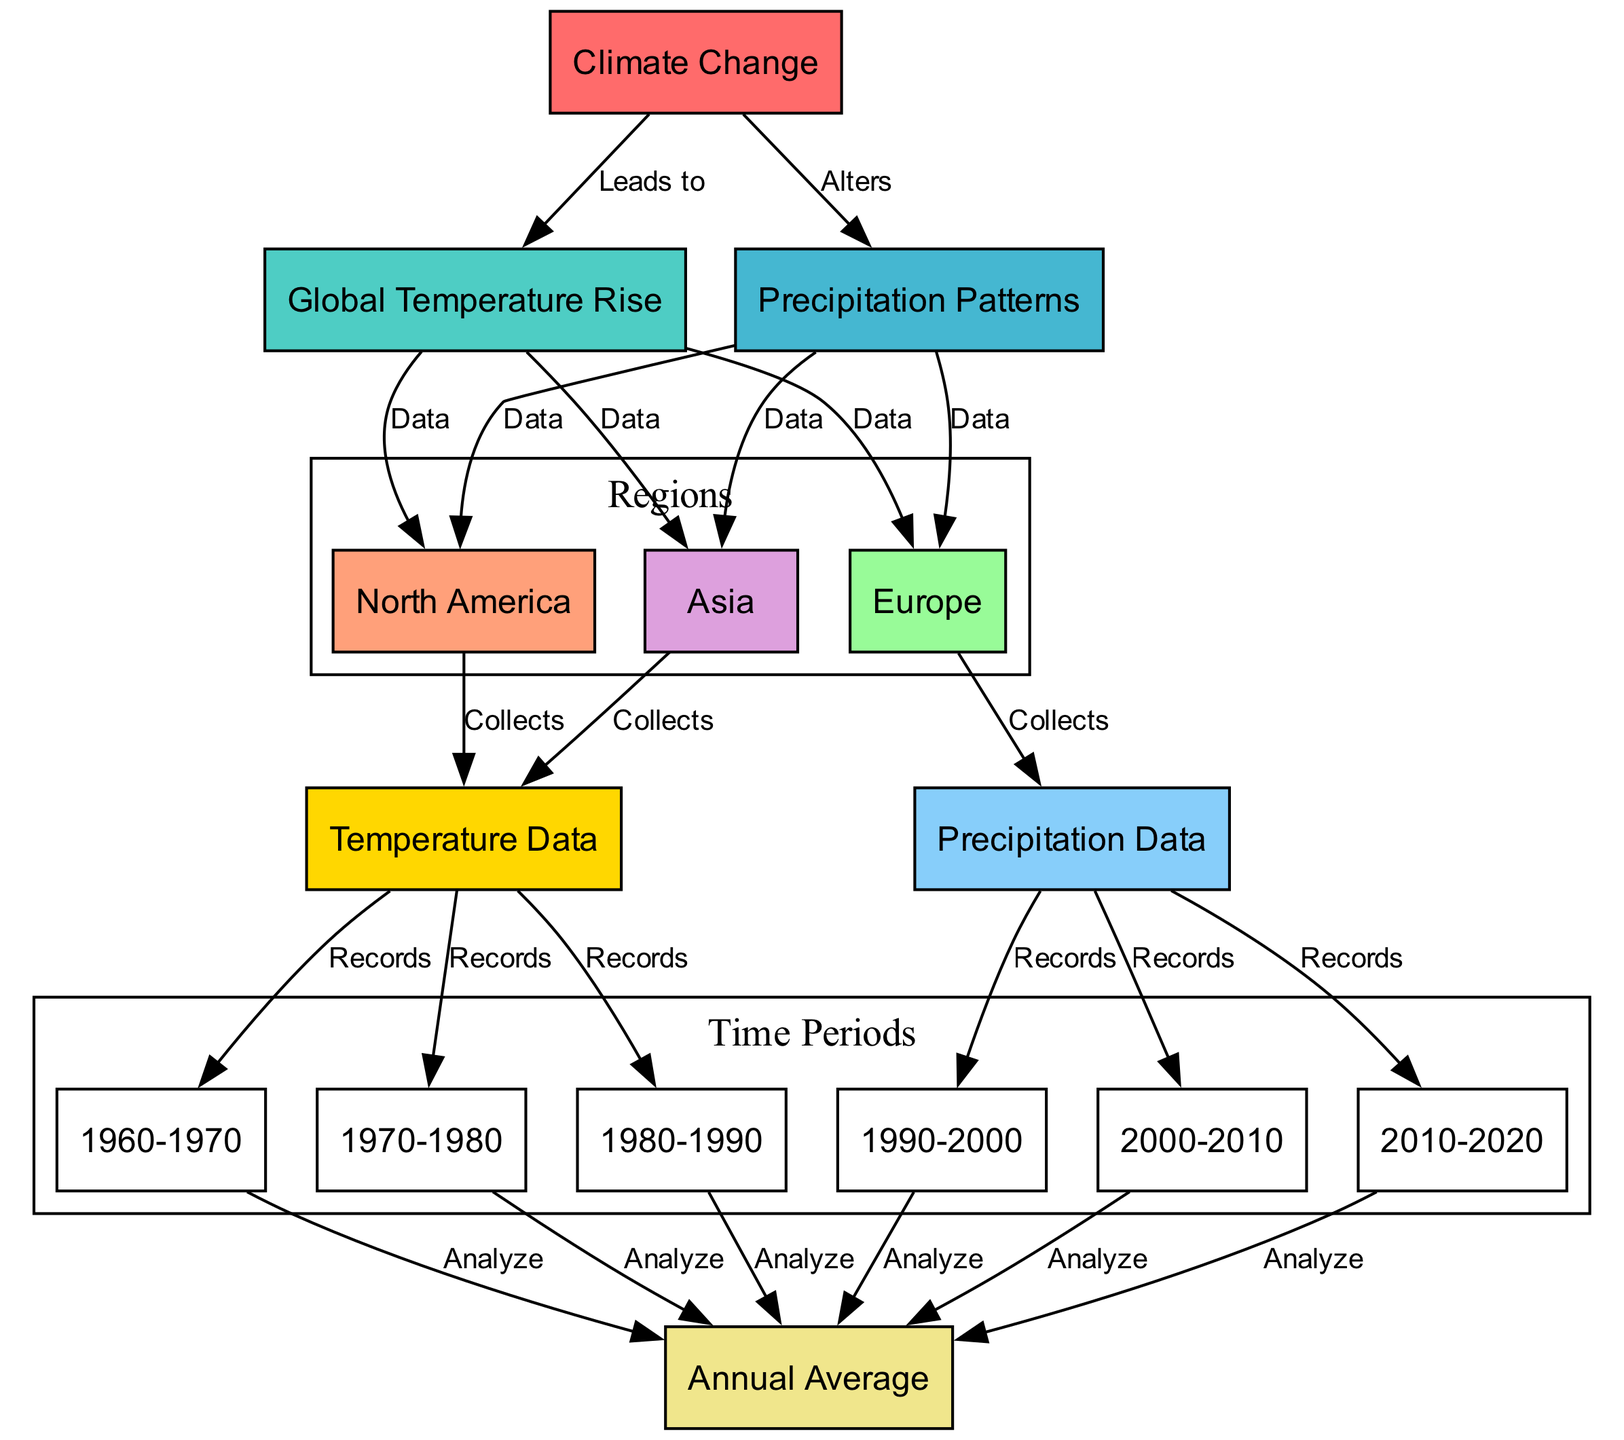What is the main impact of Climate Change? The diagram indicates that Climate Change leads to Global Temperature Rise and alters Precipitation Patterns. Thus, the primary impact is the increase in global temperatures and changes in precipitation.
Answer: Global Temperature Rise How many regions collect Temperature Data? The diagram shows three regions: North America, Europe, and Asia, each of which collects Temperature Data. Counting these regions gives us the total.
Answer: Three Which time period does Precipitation Data start recording? According to the diagram, Precipitation Data records begin in the year 1990, as it shows the connection from Precipitation Data to the time period 1990-2000.
Answer: 1990-2000 What does Global Temperature Rise connect to? The diagram has edges from Global Temperature Rise to the nodes North America, Europe, and Asia, indicating that these regions have data associated with global temperature rise. Thus, these are the nodes it connects to.
Answer: North America, Europe, Asia What is the sequence of time periods that analyze Annual Average? The diagram indicates that each of the time periods from 1960-1970 to 2010-2020 analyzes Annual Average. This requires checking the edges leading to Annual Average to determine the sequence.
Answer: 1960-1970, 1970-1980, 1980-1990, 1990-2000, 2000-2010, 2010-2020 Which two elements does Climate Change alter? The diagram explicitly shows that Climate Change alters two elements: Global Temperature Rise and Precipitation Patterns. Identifying these elements is straightforward from the edges connected to Climate Change.
Answer: Global Temperature Rise, Precipitation Patterns How many nodes are there in total? By examining the "nodes" section of the diagram data, we can count all the distinct entities listed. This gives us the total number of nodes represented in the diagram.
Answer: Fifteen Which specific data does Europe collect according to the diagram? The edge indicates that Europe specifically collects Precipitation Data as highlighted in the diagram. This is evident from tracing the connection leading from Europe.
Answer: Precipitation Data What is the relationship between Precipitation Patterns and the regions? The diagram shows that Precipitation Patterns has connections to the regions North America, Europe, and Asia, indicating that these regions have associated data. Therefore, the relationship is that all three regions are affected by changes in precipitation patterns.
Answer: North America, Europe, Asia 